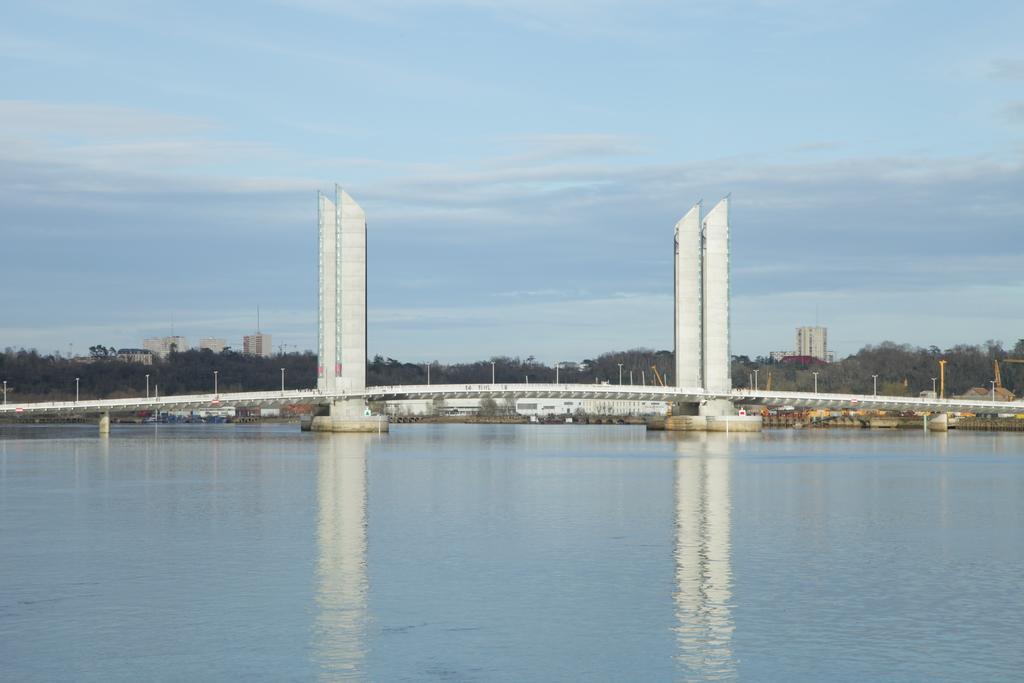Describe this image in one or two sentences. In the image in the center, we can see water. In the background, we can see the sky, clouds, trees, buildings, poles, pillars, supportive rods and one bridge. 